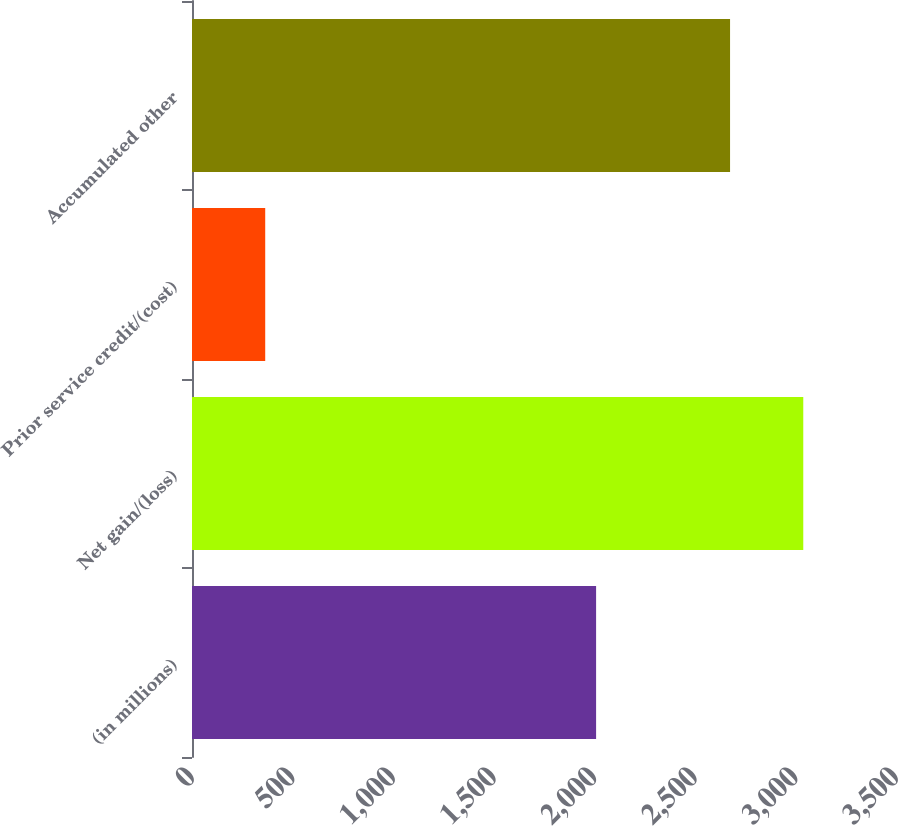Convert chart. <chart><loc_0><loc_0><loc_500><loc_500><bar_chart><fcel>(in millions)<fcel>Net gain/(loss)<fcel>Prior service credit/(cost)<fcel>Accumulated other<nl><fcel>2009<fcel>3039<fcel>364<fcel>2675<nl></chart> 